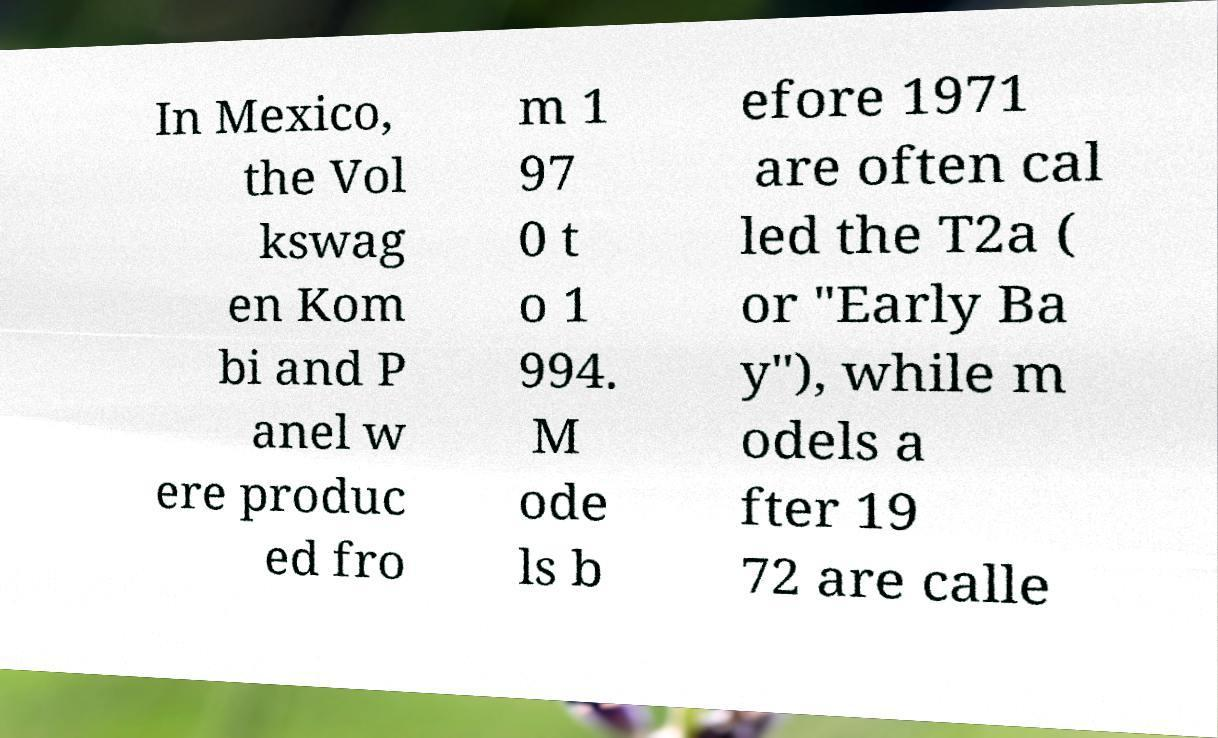Please read and relay the text visible in this image. What does it say? In Mexico, the Vol kswag en Kom bi and P anel w ere produc ed fro m 1 97 0 t o 1 994. M ode ls b efore 1971 are often cal led the T2a ( or "Early Ba y"), while m odels a fter 19 72 are calle 